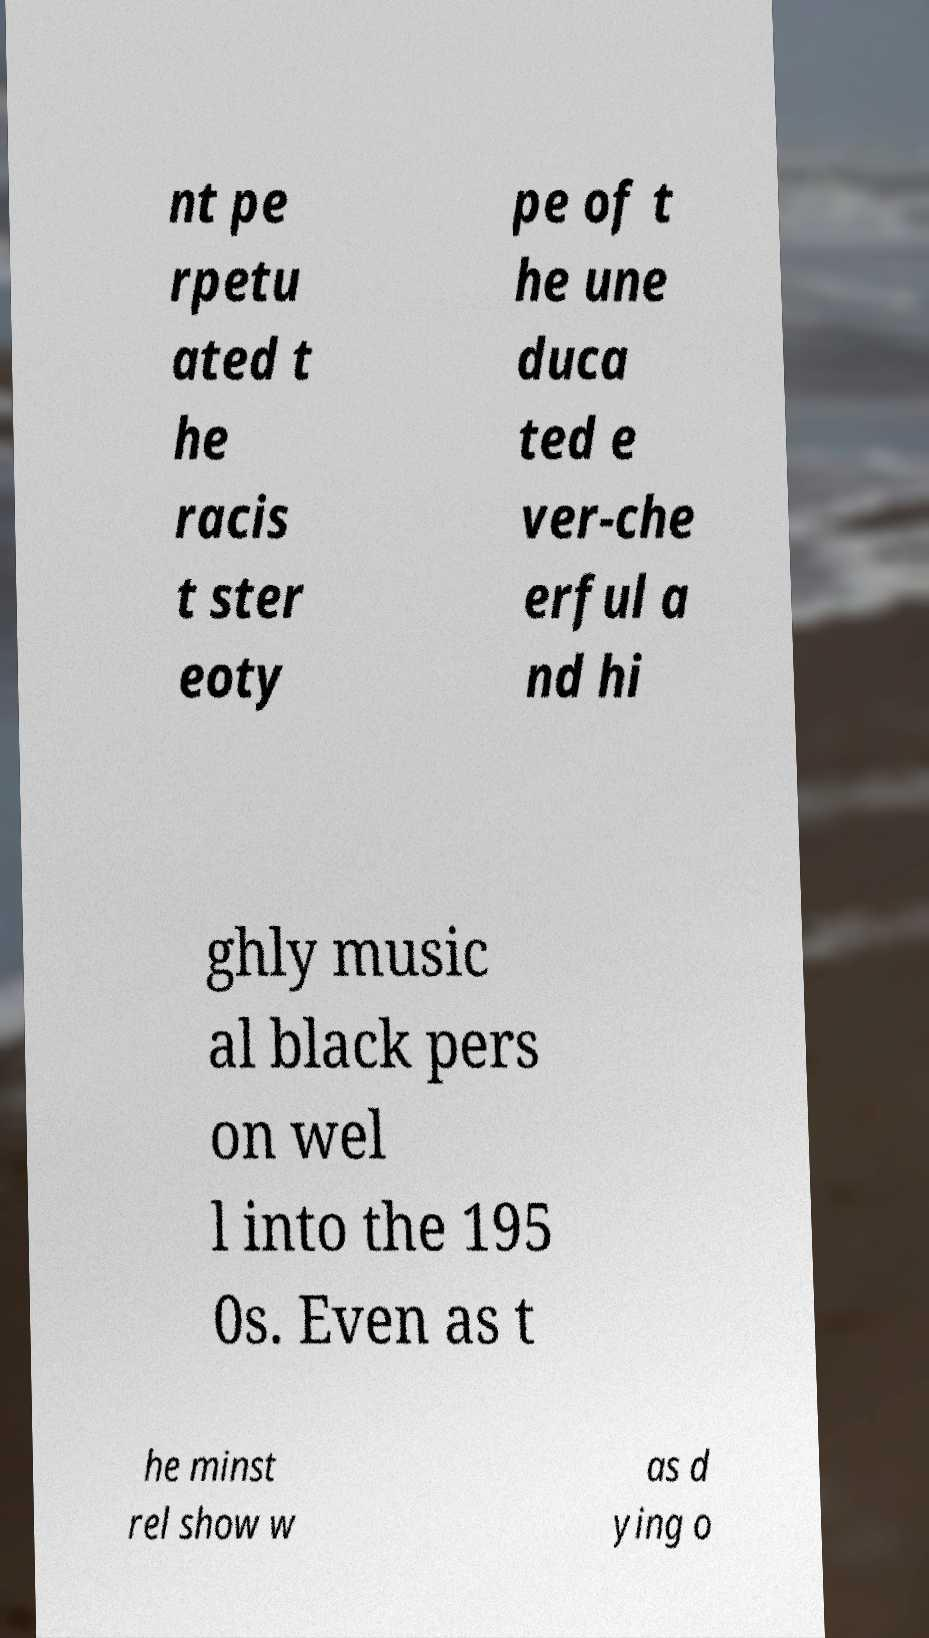What messages or text are displayed in this image? I need them in a readable, typed format. nt pe rpetu ated t he racis t ster eoty pe of t he une duca ted e ver-che erful a nd hi ghly music al black pers on wel l into the 195 0s. Even as t he minst rel show w as d ying o 